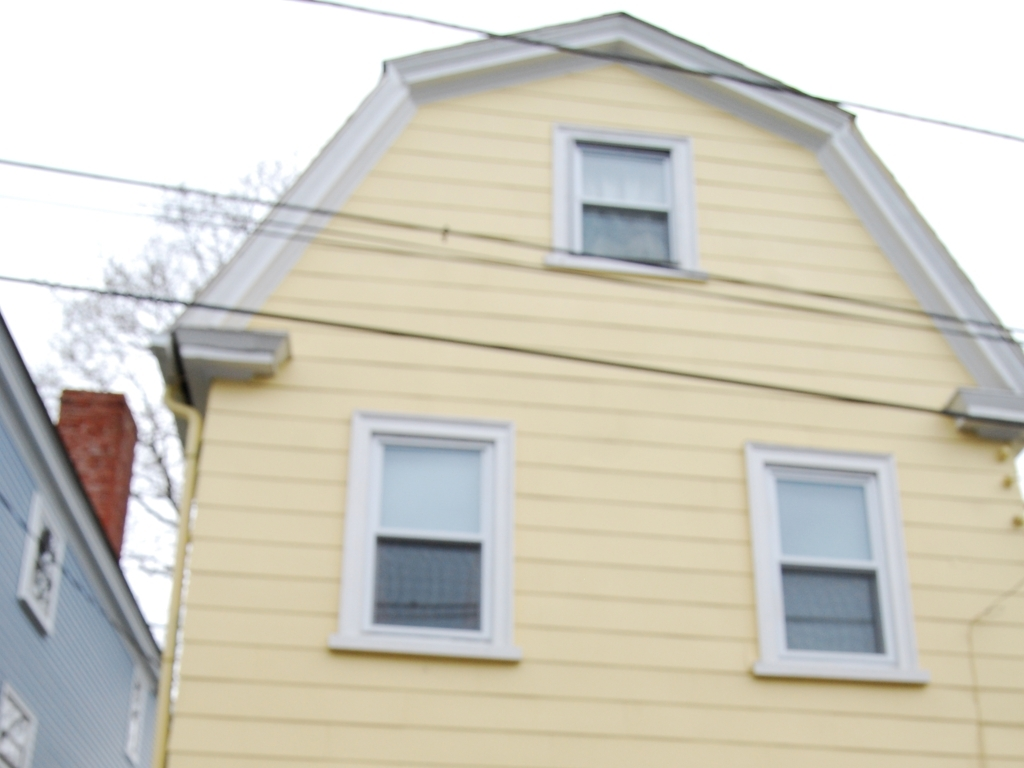What type of maintenance might the exterior of this house require? The exterior of the house, with its wooden sidings, may require regular inspections for damage or rot, a fresh coat of paint every few years to prevent wear from the elements, and gutter cleaning to prevent water damage. 